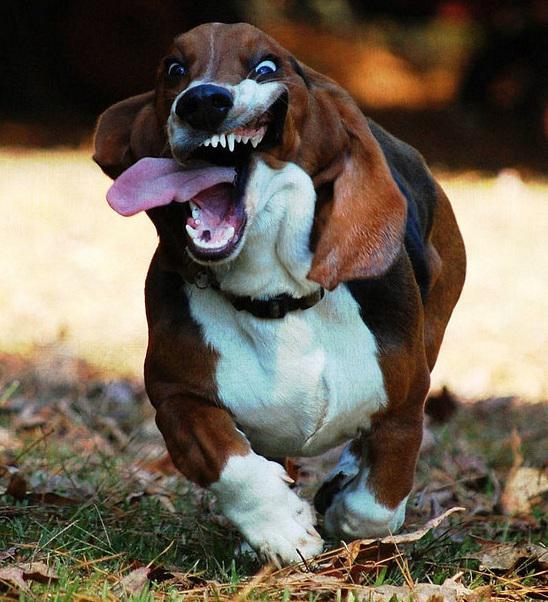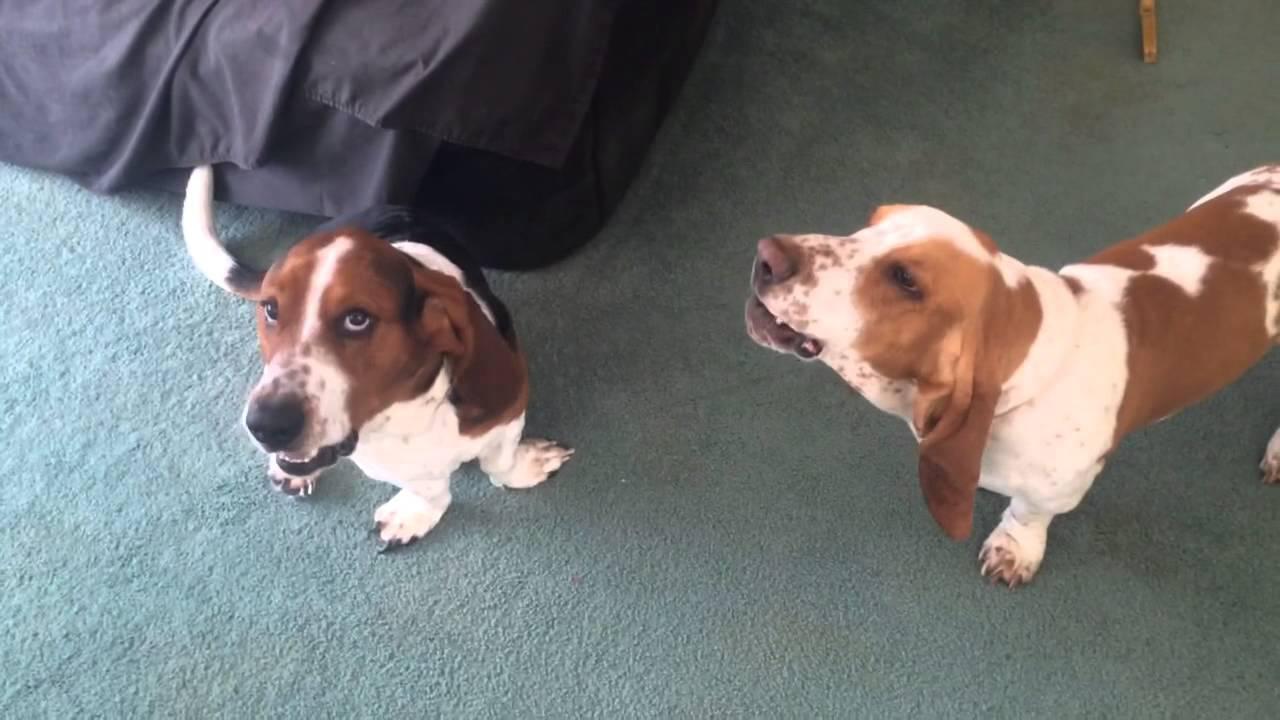The first image is the image on the left, the second image is the image on the right. Evaluate the accuracy of this statement regarding the images: "Each image contains exactly one basset hound, with one sitting and one standing.". Is it true? Answer yes or no. No. The first image is the image on the left, the second image is the image on the right. Given the left and right images, does the statement "At least one of the dogs is sitting on the grass." hold true? Answer yes or no. No. 